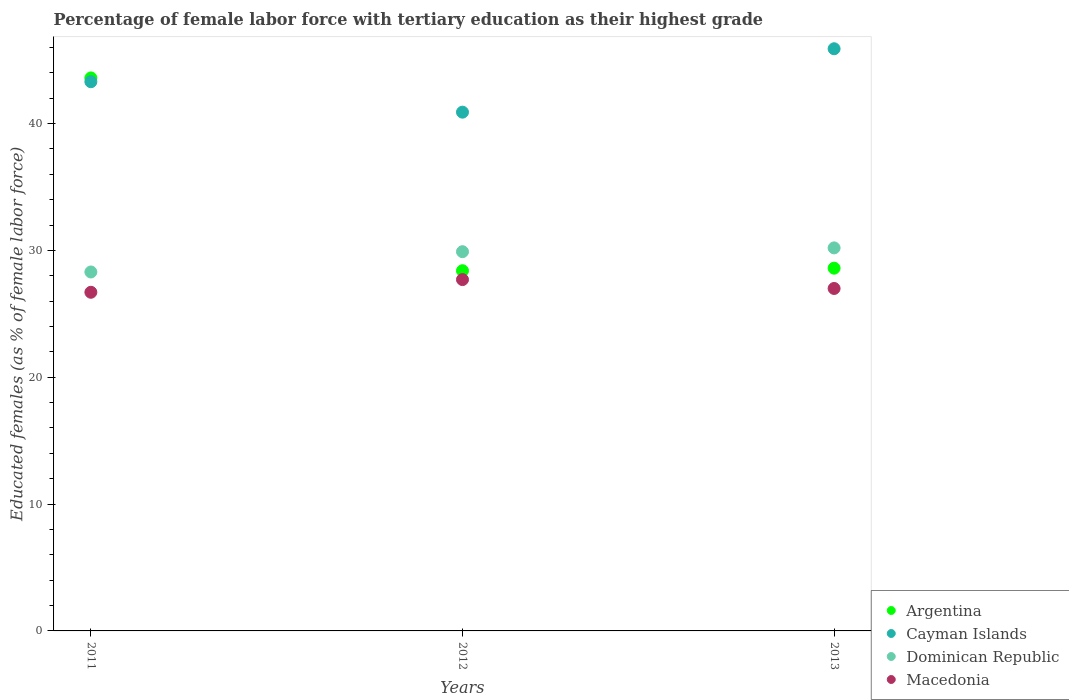Is the number of dotlines equal to the number of legend labels?
Provide a short and direct response. Yes. What is the percentage of female labor force with tertiary education in Dominican Republic in 2013?
Your response must be concise. 30.2. Across all years, what is the maximum percentage of female labor force with tertiary education in Argentina?
Your response must be concise. 43.6. Across all years, what is the minimum percentage of female labor force with tertiary education in Dominican Republic?
Keep it short and to the point. 28.3. In which year was the percentage of female labor force with tertiary education in Macedonia minimum?
Make the answer very short. 2011. What is the total percentage of female labor force with tertiary education in Argentina in the graph?
Make the answer very short. 100.6. What is the difference between the percentage of female labor force with tertiary education in Macedonia in 2011 and that in 2013?
Offer a very short reply. -0.3. What is the difference between the percentage of female labor force with tertiary education in Cayman Islands in 2011 and the percentage of female labor force with tertiary education in Dominican Republic in 2013?
Make the answer very short. 13.1. What is the average percentage of female labor force with tertiary education in Argentina per year?
Offer a very short reply. 33.53. In the year 2011, what is the difference between the percentage of female labor force with tertiary education in Macedonia and percentage of female labor force with tertiary education in Dominican Republic?
Give a very brief answer. -1.6. What is the ratio of the percentage of female labor force with tertiary education in Cayman Islands in 2011 to that in 2013?
Keep it short and to the point. 0.94. Is the difference between the percentage of female labor force with tertiary education in Macedonia in 2011 and 2012 greater than the difference between the percentage of female labor force with tertiary education in Dominican Republic in 2011 and 2012?
Give a very brief answer. Yes. What is the difference between the highest and the second highest percentage of female labor force with tertiary education in Dominican Republic?
Your answer should be compact. 0.3. What is the difference between the highest and the lowest percentage of female labor force with tertiary education in Argentina?
Your answer should be very brief. 15.2. In how many years, is the percentage of female labor force with tertiary education in Macedonia greater than the average percentage of female labor force with tertiary education in Macedonia taken over all years?
Provide a succinct answer. 1. Is the percentage of female labor force with tertiary education in Macedonia strictly greater than the percentage of female labor force with tertiary education in Dominican Republic over the years?
Ensure brevity in your answer.  No. Is the percentage of female labor force with tertiary education in Cayman Islands strictly less than the percentage of female labor force with tertiary education in Argentina over the years?
Make the answer very short. No. How many years are there in the graph?
Offer a terse response. 3. Are the values on the major ticks of Y-axis written in scientific E-notation?
Offer a very short reply. No. Does the graph contain grids?
Offer a terse response. No. How are the legend labels stacked?
Offer a terse response. Vertical. What is the title of the graph?
Your answer should be compact. Percentage of female labor force with tertiary education as their highest grade. What is the label or title of the X-axis?
Provide a succinct answer. Years. What is the label or title of the Y-axis?
Your answer should be very brief. Educated females (as % of female labor force). What is the Educated females (as % of female labor force) in Argentina in 2011?
Offer a very short reply. 43.6. What is the Educated females (as % of female labor force) in Cayman Islands in 2011?
Your answer should be very brief. 43.3. What is the Educated females (as % of female labor force) of Dominican Republic in 2011?
Offer a terse response. 28.3. What is the Educated females (as % of female labor force) of Macedonia in 2011?
Provide a short and direct response. 26.7. What is the Educated females (as % of female labor force) in Argentina in 2012?
Your answer should be compact. 28.4. What is the Educated females (as % of female labor force) of Cayman Islands in 2012?
Provide a succinct answer. 40.9. What is the Educated females (as % of female labor force) in Dominican Republic in 2012?
Provide a short and direct response. 29.9. What is the Educated females (as % of female labor force) of Macedonia in 2012?
Your response must be concise. 27.7. What is the Educated females (as % of female labor force) in Argentina in 2013?
Offer a very short reply. 28.6. What is the Educated females (as % of female labor force) in Cayman Islands in 2013?
Your answer should be very brief. 45.9. What is the Educated females (as % of female labor force) of Dominican Republic in 2013?
Ensure brevity in your answer.  30.2. Across all years, what is the maximum Educated females (as % of female labor force) of Argentina?
Your answer should be very brief. 43.6. Across all years, what is the maximum Educated females (as % of female labor force) of Cayman Islands?
Your answer should be compact. 45.9. Across all years, what is the maximum Educated females (as % of female labor force) of Dominican Republic?
Your answer should be compact. 30.2. Across all years, what is the maximum Educated females (as % of female labor force) of Macedonia?
Keep it short and to the point. 27.7. Across all years, what is the minimum Educated females (as % of female labor force) of Argentina?
Offer a terse response. 28.4. Across all years, what is the minimum Educated females (as % of female labor force) of Cayman Islands?
Offer a very short reply. 40.9. Across all years, what is the minimum Educated females (as % of female labor force) in Dominican Republic?
Keep it short and to the point. 28.3. Across all years, what is the minimum Educated females (as % of female labor force) in Macedonia?
Give a very brief answer. 26.7. What is the total Educated females (as % of female labor force) of Argentina in the graph?
Offer a very short reply. 100.6. What is the total Educated females (as % of female labor force) in Cayman Islands in the graph?
Give a very brief answer. 130.1. What is the total Educated females (as % of female labor force) of Dominican Republic in the graph?
Provide a short and direct response. 88.4. What is the total Educated females (as % of female labor force) of Macedonia in the graph?
Your answer should be compact. 81.4. What is the difference between the Educated females (as % of female labor force) in Argentina in 2011 and that in 2012?
Provide a short and direct response. 15.2. What is the difference between the Educated females (as % of female labor force) in Cayman Islands in 2011 and that in 2012?
Offer a terse response. 2.4. What is the difference between the Educated females (as % of female labor force) in Dominican Republic in 2011 and that in 2012?
Provide a succinct answer. -1.6. What is the difference between the Educated females (as % of female labor force) of Macedonia in 2011 and that in 2012?
Your answer should be compact. -1. What is the difference between the Educated females (as % of female labor force) in Macedonia in 2011 and that in 2013?
Your answer should be very brief. -0.3. What is the difference between the Educated females (as % of female labor force) in Argentina in 2012 and that in 2013?
Make the answer very short. -0.2. What is the difference between the Educated females (as % of female labor force) in Cayman Islands in 2012 and that in 2013?
Your response must be concise. -5. What is the difference between the Educated females (as % of female labor force) of Dominican Republic in 2012 and that in 2013?
Make the answer very short. -0.3. What is the difference between the Educated females (as % of female labor force) in Macedonia in 2012 and that in 2013?
Ensure brevity in your answer.  0.7. What is the difference between the Educated females (as % of female labor force) of Argentina in 2011 and the Educated females (as % of female labor force) of Dominican Republic in 2012?
Keep it short and to the point. 13.7. What is the difference between the Educated females (as % of female labor force) in Argentina in 2011 and the Educated females (as % of female labor force) in Macedonia in 2012?
Ensure brevity in your answer.  15.9. What is the difference between the Educated females (as % of female labor force) in Cayman Islands in 2011 and the Educated females (as % of female labor force) in Dominican Republic in 2012?
Provide a succinct answer. 13.4. What is the difference between the Educated females (as % of female labor force) of Argentina in 2011 and the Educated females (as % of female labor force) of Dominican Republic in 2013?
Offer a terse response. 13.4. What is the difference between the Educated females (as % of female labor force) in Argentina in 2011 and the Educated females (as % of female labor force) in Macedonia in 2013?
Your response must be concise. 16.6. What is the difference between the Educated females (as % of female labor force) in Cayman Islands in 2011 and the Educated females (as % of female labor force) in Dominican Republic in 2013?
Make the answer very short. 13.1. What is the difference between the Educated females (as % of female labor force) of Argentina in 2012 and the Educated females (as % of female labor force) of Cayman Islands in 2013?
Make the answer very short. -17.5. What is the difference between the Educated females (as % of female labor force) of Argentina in 2012 and the Educated females (as % of female labor force) of Dominican Republic in 2013?
Ensure brevity in your answer.  -1.8. What is the average Educated females (as % of female labor force) in Argentina per year?
Provide a short and direct response. 33.53. What is the average Educated females (as % of female labor force) in Cayman Islands per year?
Give a very brief answer. 43.37. What is the average Educated females (as % of female labor force) of Dominican Republic per year?
Give a very brief answer. 29.47. What is the average Educated females (as % of female labor force) of Macedonia per year?
Offer a terse response. 27.13. In the year 2011, what is the difference between the Educated females (as % of female labor force) in Argentina and Educated females (as % of female labor force) in Cayman Islands?
Your response must be concise. 0.3. In the year 2011, what is the difference between the Educated females (as % of female labor force) of Argentina and Educated females (as % of female labor force) of Dominican Republic?
Keep it short and to the point. 15.3. In the year 2011, what is the difference between the Educated females (as % of female labor force) in Argentina and Educated females (as % of female labor force) in Macedonia?
Provide a succinct answer. 16.9. In the year 2011, what is the difference between the Educated females (as % of female labor force) of Cayman Islands and Educated females (as % of female labor force) of Dominican Republic?
Offer a terse response. 15. In the year 2011, what is the difference between the Educated females (as % of female labor force) of Dominican Republic and Educated females (as % of female labor force) of Macedonia?
Your response must be concise. 1.6. In the year 2012, what is the difference between the Educated females (as % of female labor force) in Argentina and Educated females (as % of female labor force) in Dominican Republic?
Your response must be concise. -1.5. In the year 2012, what is the difference between the Educated females (as % of female labor force) in Cayman Islands and Educated females (as % of female labor force) in Dominican Republic?
Ensure brevity in your answer.  11. In the year 2012, what is the difference between the Educated females (as % of female labor force) in Dominican Republic and Educated females (as % of female labor force) in Macedonia?
Provide a succinct answer. 2.2. In the year 2013, what is the difference between the Educated females (as % of female labor force) of Argentina and Educated females (as % of female labor force) of Cayman Islands?
Your answer should be very brief. -17.3. In the year 2013, what is the difference between the Educated females (as % of female labor force) of Argentina and Educated females (as % of female labor force) of Macedonia?
Your answer should be very brief. 1.6. In the year 2013, what is the difference between the Educated females (as % of female labor force) of Cayman Islands and Educated females (as % of female labor force) of Dominican Republic?
Offer a very short reply. 15.7. What is the ratio of the Educated females (as % of female labor force) of Argentina in 2011 to that in 2012?
Give a very brief answer. 1.54. What is the ratio of the Educated females (as % of female labor force) in Cayman Islands in 2011 to that in 2012?
Offer a terse response. 1.06. What is the ratio of the Educated females (as % of female labor force) of Dominican Republic in 2011 to that in 2012?
Make the answer very short. 0.95. What is the ratio of the Educated females (as % of female labor force) in Macedonia in 2011 to that in 2012?
Provide a succinct answer. 0.96. What is the ratio of the Educated females (as % of female labor force) in Argentina in 2011 to that in 2013?
Keep it short and to the point. 1.52. What is the ratio of the Educated females (as % of female labor force) in Cayman Islands in 2011 to that in 2013?
Keep it short and to the point. 0.94. What is the ratio of the Educated females (as % of female labor force) in Dominican Republic in 2011 to that in 2013?
Ensure brevity in your answer.  0.94. What is the ratio of the Educated females (as % of female labor force) of Macedonia in 2011 to that in 2013?
Keep it short and to the point. 0.99. What is the ratio of the Educated females (as % of female labor force) in Cayman Islands in 2012 to that in 2013?
Make the answer very short. 0.89. What is the ratio of the Educated females (as % of female labor force) in Macedonia in 2012 to that in 2013?
Make the answer very short. 1.03. What is the difference between the highest and the second highest Educated females (as % of female labor force) in Argentina?
Offer a very short reply. 15. What is the difference between the highest and the second highest Educated females (as % of female labor force) in Cayman Islands?
Your response must be concise. 2.6. What is the difference between the highest and the second highest Educated females (as % of female labor force) in Dominican Republic?
Make the answer very short. 0.3. What is the difference between the highest and the lowest Educated females (as % of female labor force) in Dominican Republic?
Your response must be concise. 1.9. What is the difference between the highest and the lowest Educated females (as % of female labor force) in Macedonia?
Offer a terse response. 1. 